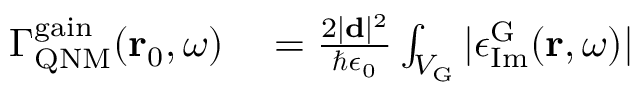Convert formula to latex. <formula><loc_0><loc_0><loc_500><loc_500>\begin{array} { r l } { \Gamma _ { Q N M } ^ { g a i n } ( r _ { 0 } , \omega ) } & = \frac { 2 | d | ^ { 2 } } { \hbar { \epsilon } _ { 0 } } \int _ { V _ { G } } | \epsilon _ { I m } ^ { G } ( r , \omega ) | } \end{array}</formula> 